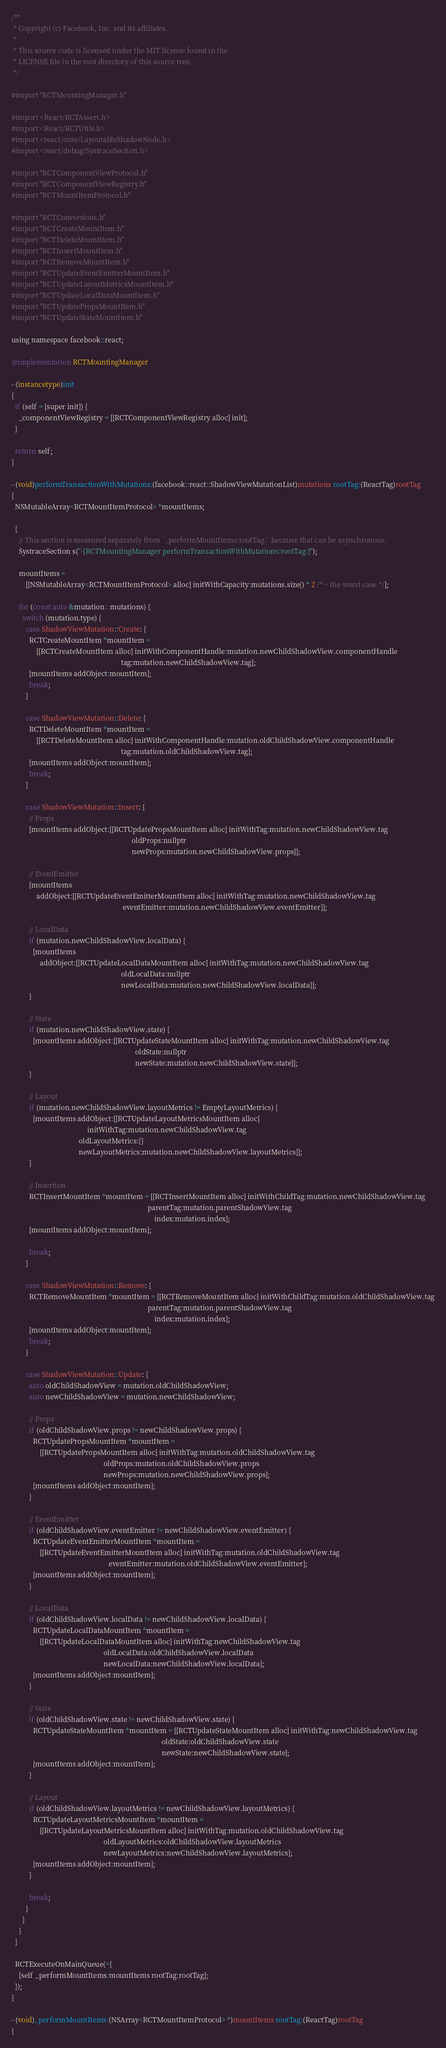Convert code to text. <code><loc_0><loc_0><loc_500><loc_500><_ObjectiveC_>/**
 * Copyright (c) Facebook, Inc. and its affiliates.
 *
 * This source code is licensed under the MIT license found in the
 * LICENSE file in the root directory of this source tree.
 */

#import "RCTMountingManager.h"

#import <React/RCTAssert.h>
#import <React/RCTUtils.h>
#import <react/core/LayoutableShadowNode.h>
#import <react/debug/SystraceSection.h>

#import "RCTComponentViewProtocol.h"
#import "RCTComponentViewRegistry.h"
#import "RCTMountItemProtocol.h"

#import "RCTConversions.h"
#import "RCTCreateMountItem.h"
#import "RCTDeleteMountItem.h"
#import "RCTInsertMountItem.h"
#import "RCTRemoveMountItem.h"
#import "RCTUpdateEventEmitterMountItem.h"
#import "RCTUpdateLayoutMetricsMountItem.h"
#import "RCTUpdateLocalDataMountItem.h"
#import "RCTUpdatePropsMountItem.h"
#import "RCTUpdateStateMountItem.h"

using namespace facebook::react;

@implementation RCTMountingManager

- (instancetype)init
{
  if (self = [super init]) {
    _componentViewRegistry = [[RCTComponentViewRegistry alloc] init];
  }

  return self;
}

- (void)performTransactionWithMutations:(facebook::react::ShadowViewMutationList)mutations rootTag:(ReactTag)rootTag
{
  NSMutableArray<RCTMountItemProtocol> *mountItems;

  {
    // This section is measured separately from `_performMountItems:rootTag:` because that can be asynchronous.
    SystraceSection s("-[RCTMountingManager performTransactionWithMutations:rootTag:]");

    mountItems =
        [[NSMutableArray<RCTMountItemProtocol> alloc] initWithCapacity:mutations.size() * 2 /* ~ the worst case */];

    for (const auto &mutation : mutations) {
      switch (mutation.type) {
        case ShadowViewMutation::Create: {
          RCTCreateMountItem *mountItem =
              [[RCTCreateMountItem alloc] initWithComponentHandle:mutation.newChildShadowView.componentHandle
                                                              tag:mutation.newChildShadowView.tag];
          [mountItems addObject:mountItem];
          break;
        }

        case ShadowViewMutation::Delete: {
          RCTDeleteMountItem *mountItem =
              [[RCTDeleteMountItem alloc] initWithComponentHandle:mutation.oldChildShadowView.componentHandle
                                                              tag:mutation.oldChildShadowView.tag];
          [mountItems addObject:mountItem];
          break;
        }

        case ShadowViewMutation::Insert: {
          // Props
          [mountItems addObject:[[RCTUpdatePropsMountItem alloc] initWithTag:mutation.newChildShadowView.tag
                                                                    oldProps:nullptr
                                                                    newProps:mutation.newChildShadowView.props]];

          // EventEmitter
          [mountItems
              addObject:[[RCTUpdateEventEmitterMountItem alloc] initWithTag:mutation.newChildShadowView.tag
                                                               eventEmitter:mutation.newChildShadowView.eventEmitter]];

          // LocalData
          if (mutation.newChildShadowView.localData) {
            [mountItems
                addObject:[[RCTUpdateLocalDataMountItem alloc] initWithTag:mutation.newChildShadowView.tag
                                                              oldLocalData:nullptr
                                                              newLocalData:mutation.newChildShadowView.localData]];
          }

          // State
          if (mutation.newChildShadowView.state) {
            [mountItems addObject:[[RCTUpdateStateMountItem alloc] initWithTag:mutation.newChildShadowView.tag
                                                                      oldState:nullptr
                                                                      newState:mutation.newChildShadowView.state]];
          }

          // Layout
          if (mutation.newChildShadowView.layoutMetrics != EmptyLayoutMetrics) {
            [mountItems addObject:[[RCTUpdateLayoutMetricsMountItem alloc]
                                           initWithTag:mutation.newChildShadowView.tag
                                      oldLayoutMetrics:{}
                                      newLayoutMetrics:mutation.newChildShadowView.layoutMetrics]];
          }

          // Insertion
          RCTInsertMountItem *mountItem = [[RCTInsertMountItem alloc] initWithChildTag:mutation.newChildShadowView.tag
                                                                             parentTag:mutation.parentShadowView.tag
                                                                                 index:mutation.index];
          [mountItems addObject:mountItem];

          break;
        }

        case ShadowViewMutation::Remove: {
          RCTRemoveMountItem *mountItem = [[RCTRemoveMountItem alloc] initWithChildTag:mutation.oldChildShadowView.tag
                                                                             parentTag:mutation.parentShadowView.tag
                                                                                 index:mutation.index];
          [mountItems addObject:mountItem];
          break;
        }

        case ShadowViewMutation::Update: {
          auto oldChildShadowView = mutation.oldChildShadowView;
          auto newChildShadowView = mutation.newChildShadowView;

          // Props
          if (oldChildShadowView.props != newChildShadowView.props) {
            RCTUpdatePropsMountItem *mountItem =
                [[RCTUpdatePropsMountItem alloc] initWithTag:mutation.oldChildShadowView.tag
                                                    oldProps:mutation.oldChildShadowView.props
                                                    newProps:mutation.newChildShadowView.props];
            [mountItems addObject:mountItem];
          }

          // EventEmitter
          if (oldChildShadowView.eventEmitter != newChildShadowView.eventEmitter) {
            RCTUpdateEventEmitterMountItem *mountItem =
                [[RCTUpdateEventEmitterMountItem alloc] initWithTag:mutation.oldChildShadowView.tag
                                                       eventEmitter:mutation.oldChildShadowView.eventEmitter];
            [mountItems addObject:mountItem];
          }

          // LocalData
          if (oldChildShadowView.localData != newChildShadowView.localData) {
            RCTUpdateLocalDataMountItem *mountItem =
                [[RCTUpdateLocalDataMountItem alloc] initWithTag:newChildShadowView.tag
                                                    oldLocalData:oldChildShadowView.localData
                                                    newLocalData:newChildShadowView.localData];
            [mountItems addObject:mountItem];
          }

          // State
          if (oldChildShadowView.state != newChildShadowView.state) {
            RCTUpdateStateMountItem *mountItem = [[RCTUpdateStateMountItem alloc] initWithTag:newChildShadowView.tag
                                                                                     oldState:oldChildShadowView.state
                                                                                     newState:newChildShadowView.state];
            [mountItems addObject:mountItem];
          }

          // Layout
          if (oldChildShadowView.layoutMetrics != newChildShadowView.layoutMetrics) {
            RCTUpdateLayoutMetricsMountItem *mountItem =
                [[RCTUpdateLayoutMetricsMountItem alloc] initWithTag:mutation.oldChildShadowView.tag
                                                    oldLayoutMetrics:oldChildShadowView.layoutMetrics
                                                    newLayoutMetrics:newChildShadowView.layoutMetrics];
            [mountItems addObject:mountItem];
          }

          break;
        }
      }
    }
  }

  RCTExecuteOnMainQueue(^{
    [self _performMountItems:mountItems rootTag:rootTag];
  });
}

- (void)_performMountItems:(NSArray<RCTMountItemProtocol> *)mountItems rootTag:(ReactTag)rootTag
{</code> 